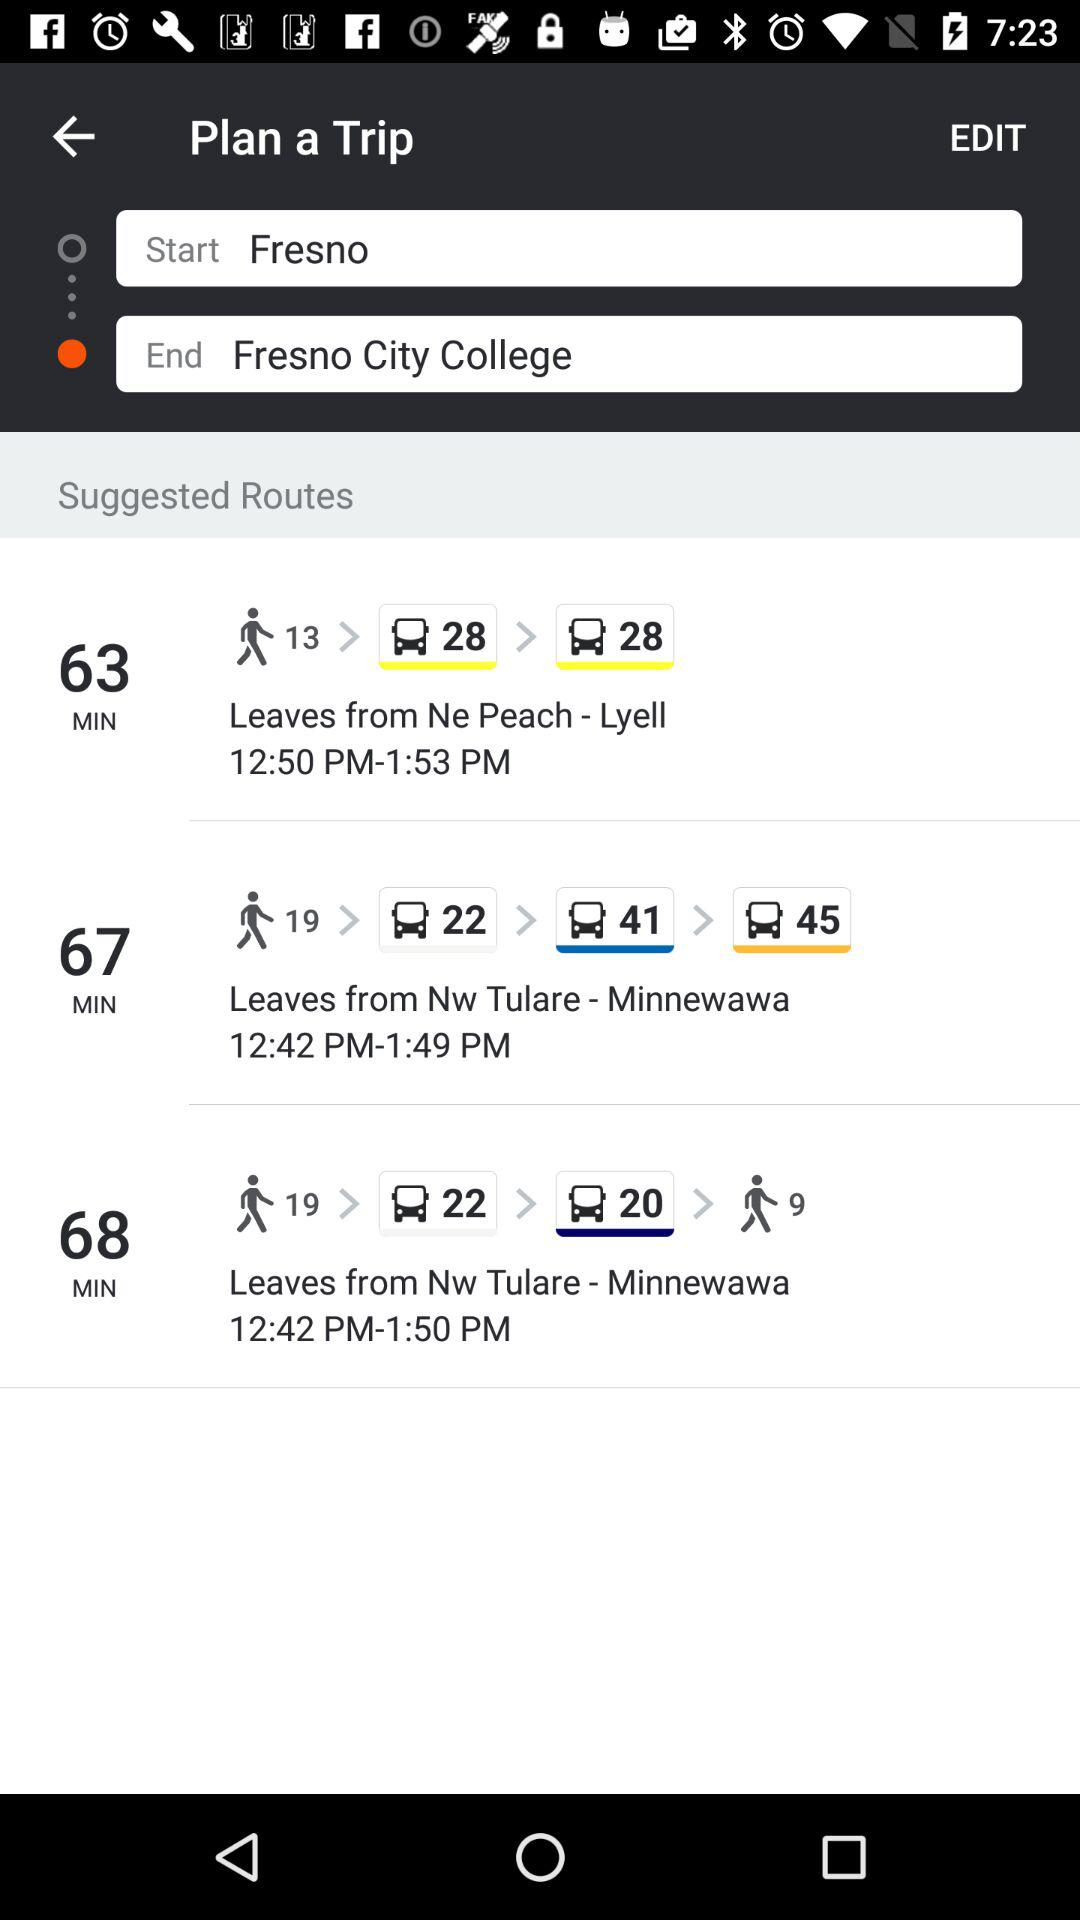At what time does the bus leave from NW Tulare? The bus leaves at 12:42 PM from NW Tulare. 